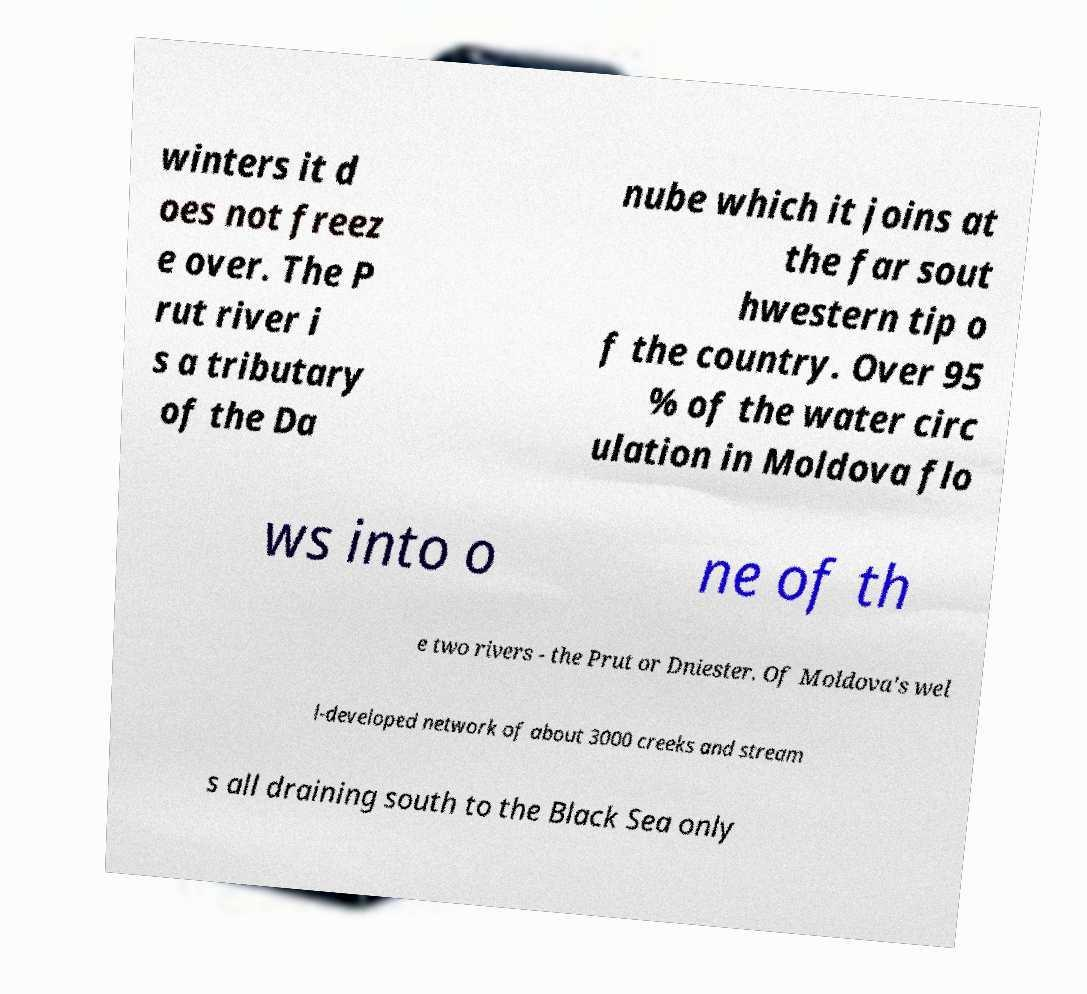I need the written content from this picture converted into text. Can you do that? winters it d oes not freez e over. The P rut river i s a tributary of the Da nube which it joins at the far sout hwestern tip o f the country. Over 95 % of the water circ ulation in Moldova flo ws into o ne of th e two rivers - the Prut or Dniester. Of Moldova's wel l-developed network of about 3000 creeks and stream s all draining south to the Black Sea only 